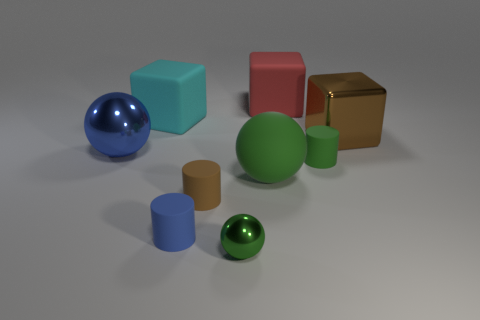Subtract all green matte cylinders. How many cylinders are left? 2 Subtract 1 balls. How many balls are left? 2 Subtract all green cylinders. How many red cubes are left? 1 Add 1 brown matte cylinders. How many brown matte cylinders exist? 2 Subtract all brown blocks. How many blocks are left? 2 Subtract 0 yellow cubes. How many objects are left? 9 Subtract all blocks. How many objects are left? 6 Subtract all red cylinders. Subtract all cyan spheres. How many cylinders are left? 3 Subtract all large brown objects. Subtract all brown shiny objects. How many objects are left? 7 Add 5 small brown rubber objects. How many small brown rubber objects are left? 6 